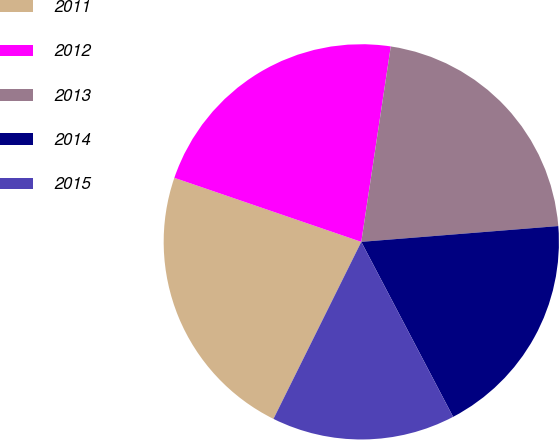Convert chart. <chart><loc_0><loc_0><loc_500><loc_500><pie_chart><fcel>2011<fcel>2012<fcel>2013<fcel>2014<fcel>2015<nl><fcel>22.92%<fcel>22.13%<fcel>21.34%<fcel>18.58%<fcel>15.02%<nl></chart> 